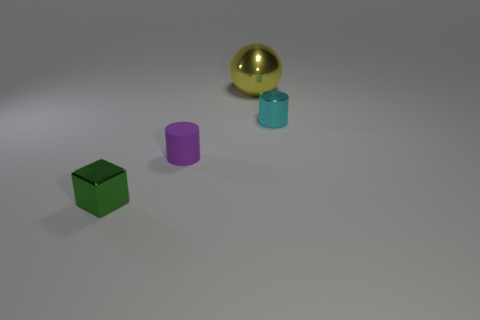How many blue blocks are there?
Your answer should be compact. 0. What material is the small cyan thing that is the same shape as the purple object?
Give a very brief answer. Metal. Are the small cylinder that is in front of the cyan metallic object and the small cyan thing made of the same material?
Give a very brief answer. No. Is the number of green blocks that are in front of the small matte cylinder greater than the number of small cyan metal things behind the ball?
Provide a short and direct response. Yes. What size is the yellow metal ball?
Provide a short and direct response. Large. There is a yellow object that is the same material as the cube; what shape is it?
Provide a succinct answer. Sphere. Does the small metal object that is behind the green metallic object have the same shape as the purple rubber object?
Your response must be concise. Yes. What number of objects are either big shiny things or big green matte objects?
Give a very brief answer. 1. There is a object that is on the right side of the small green shiny block and to the left of the metal sphere; what is its material?
Provide a succinct answer. Rubber. Is the cyan object the same size as the cube?
Offer a very short reply. Yes. 